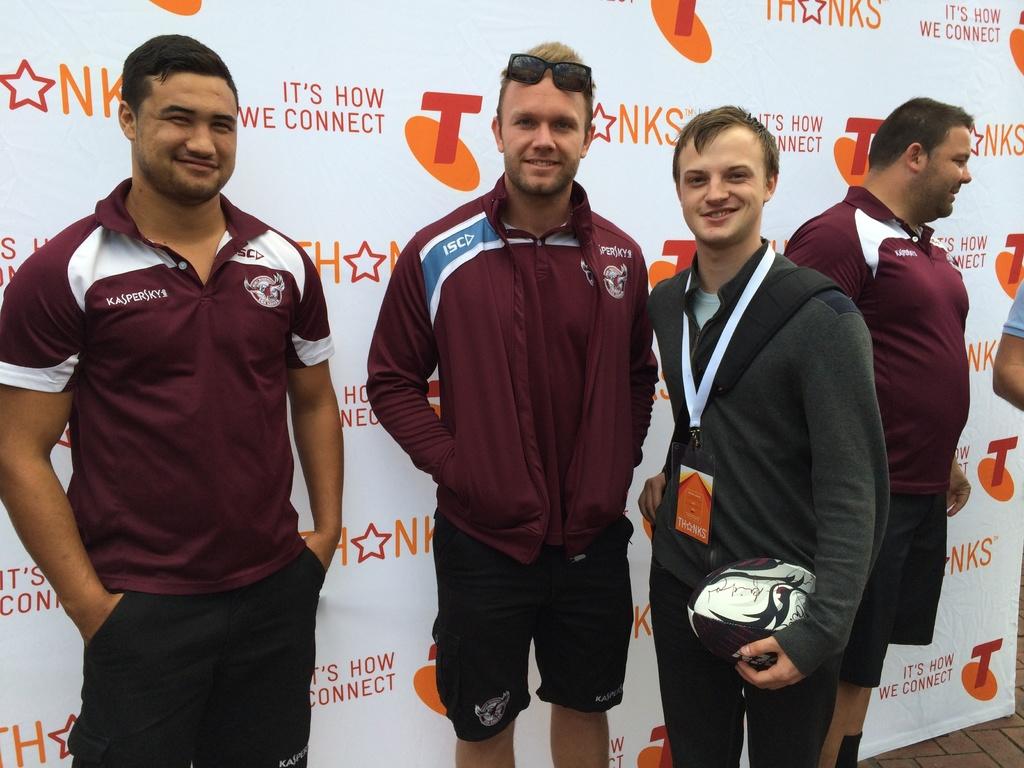What is the slogan printed on the "thanks" advertisement behind these rugby players?
Your response must be concise. It's how we connect. 